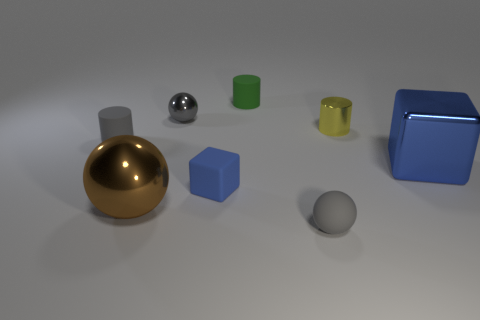What color is the shiny ball that is the same size as the yellow cylinder?
Provide a succinct answer. Gray. How many matte objects are small blue things or small gray spheres?
Make the answer very short. 2. Is the number of rubber cylinders the same as the number of matte cubes?
Offer a terse response. No. How many tiny cylinders are behind the gray metallic object and on the right side of the tiny gray matte sphere?
Your answer should be very brief. 0. Is there anything else that is the same shape as the yellow thing?
Keep it short and to the point. Yes. How many other things are the same size as the rubber block?
Offer a terse response. 5. Does the metal ball in front of the small blue matte thing have the same size as the object that is in front of the brown thing?
Provide a succinct answer. No. What number of things are either rubber cylinders or large metal objects behind the brown sphere?
Give a very brief answer. 3. How big is the gray thing right of the green rubber cylinder?
Give a very brief answer. Small. Is the number of large things in front of the tiny blue matte thing less than the number of small green rubber cylinders that are on the left side of the large brown ball?
Provide a short and direct response. No. 